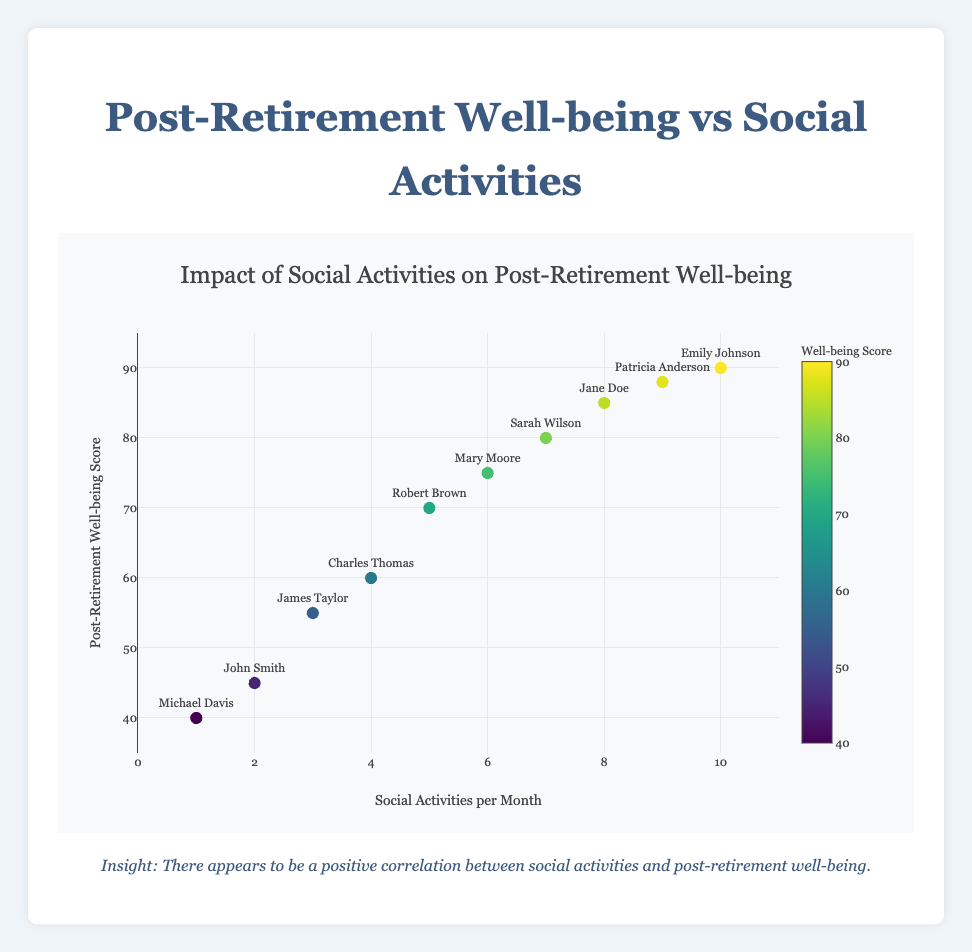What is the title of the scatter plot? The title is found at the top of the figure and describes the main focus of the scatter plot. It should concisely summarize what the x and y axes represent.
Answer: Impact of Social Activities on Post-Retirement Well-being What is the range of the x-axis? The range of the x-axis can be determined by looking at its minimum and maximum values on the plot. The x-axis represents the number of social activities per month.
Answer: 0 to 11 What kind of correlation is suggested between social activities per month and post-retirement well-being scores? A correlation describes how two variables are related. By observing whether the points tend to increase together, decrease together, or have no clear pattern, we can infer positive, negative, or no correlation.
Answer: Positive correlation Which individual has the highest post-retirement well-being score? Looking at the y-axis for the highest value and then identifying the corresponding individual from the text labels of each data point will provide this information.
Answer: Emily Johnson How many individuals participate in social activities more than 7 times per month? This can be determined by counting the number of data points where the x-axis value is greater than 7.
Answer: 3 What is the average post-retirement well-being score for individuals participating in 6 or more social activities per month? Sum the well-being scores of individuals participating in 6 or more activities (75+80+85+88+90), then divide by the number of those individuals (5).
Answer: 83.6 Is there any individual with a post-retirement well-being score below 50? If so, who? By checking the y-axis for scores below 50, we can see which individuals fall into this category based on their labels.
Answer: Yes, John Smith and Michael Davis Compare the well-being scores of Sarah Wilson and Patricia Anderson. Who has a higher score? Locate the data points for both Sarah Wilson and Patricia Anderson and compare the y-axis values.
Answer: Patricia Anderson What is the color of the data point representing an individual with a well-being score of 60? The color of the markers is based on the well-being score and follows a color scale. By looking at the color scale and the marker color for the score of 60, we find the answer.
Answer: Varies (depending on the color mapping) How do the data points of individuals with exactly 3 and 4 social activities per month compare in terms of well-being scores? Find the points for 3 and 4 social activities per month on the x-axis, and then compare their y-axis well-being scores.
Answer: Score for 3 activities: 55; Score for 4 activities: 60 